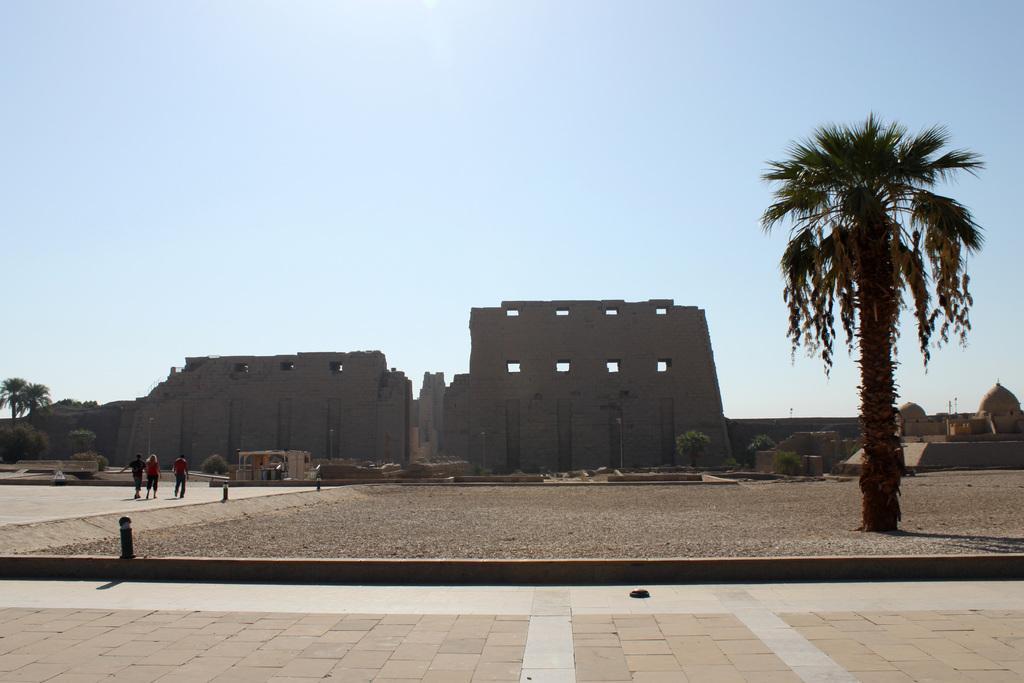In one or two sentences, can you explain what this image depicts? In this image, we can see people, trees, plants, ground, walkways and few objects. Background we can see forts, walls and sky. 